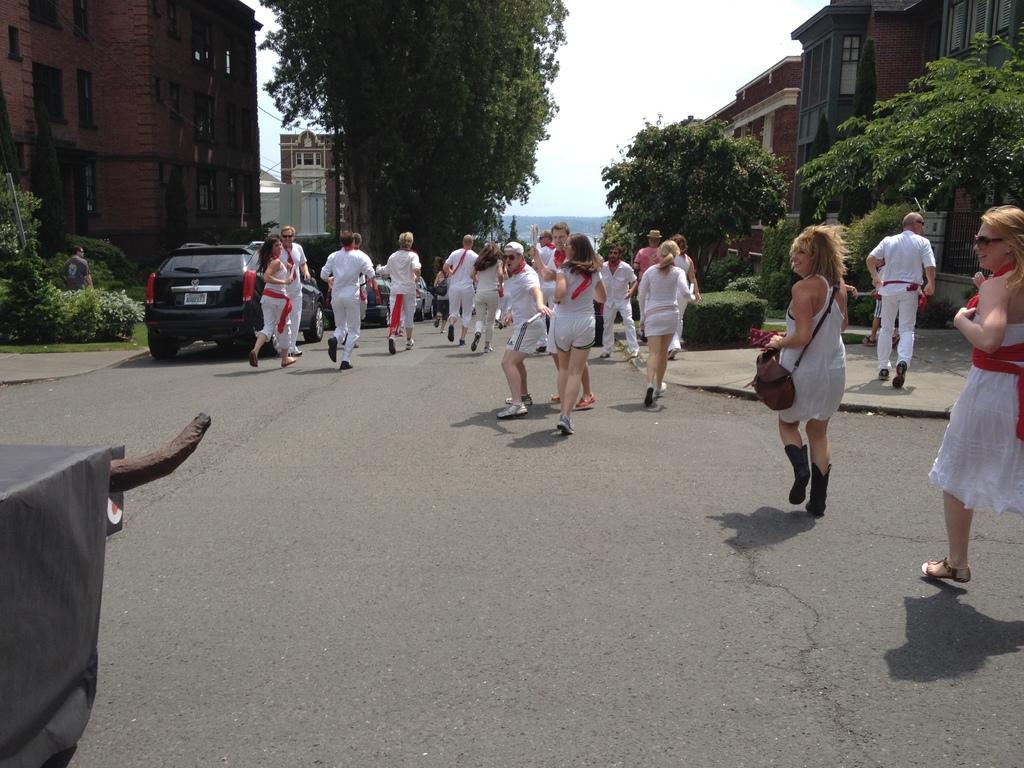Can you describe this image briefly? In this image I can see a road , on the road I can see group of persons, vehicles, and beside the road I can see buildings, trees, there is a persons visible in front of bushes on the left side , in the middle there is the sky visible. 